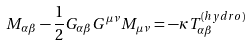Convert formula to latex. <formula><loc_0><loc_0><loc_500><loc_500>M _ { \alpha \beta } - \frac { 1 } { 2 } G _ { \alpha \beta } G ^ { \mu \nu } M _ { \mu \nu } = - \kappa T _ { \alpha \beta } ^ { ( h y d r o ) }</formula> 